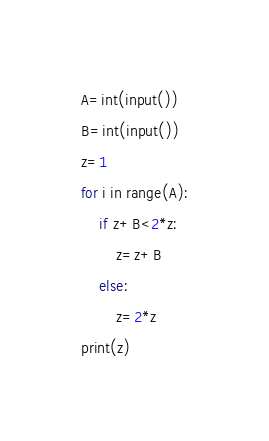<code> <loc_0><loc_0><loc_500><loc_500><_Python_>A=int(input())
B=int(input())
z=1
for i in range(A):
	if z+B<2*z:
		z=z+B
	else:
		z=2*z
print(z)</code> 